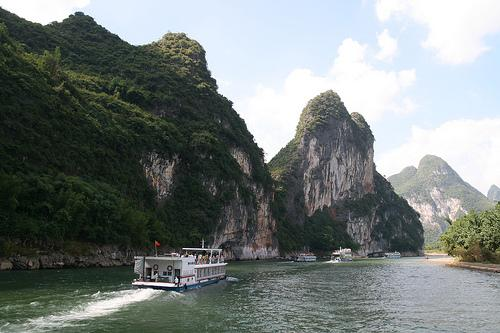Identify the color of the sky and body of water in the image. The sky displays a clear blue hue, while the body of water reveals a calm green color. Can you identify an object in the image which might symbolize safety and what color is it? There are two life rings on the back of the white boat, likely symbolizing safety in case of emergency situations. Describe the key elements of this image in the context of a tourism promotion. The image showcases scenic green river views, a sightseeing boat with ample windows and space for tourists, a beautiful blue sky, and breathtaking landscapes of rocky mountains rich in lush greenery and foliage. What does the image suggest about the activities of people on the boat? The image suggests that many people are aboard the boat, likely enjoying the sightseeing tour, with some standing on the top deck observing the natural beauty around them. What type of experience do you think the people on the boat might be having? The people on the boat are likely having a relaxing and enjoyable sightseeing experience while they take in the beautiful surrounding nature and verdant landscapes. Can you spot any evidence indicating that the boat is in motion? If so, describe it. Yes, there is evidence of the boat being in motion; the white waves and the water churned up to a white color from the boat's motor both indicate that it is moving. How many objects can you count in the image when referring to the objects that are on the water? There are three objects on the water: the main tour boat, the white waves caused by the boat, and the wake of the boat. What is the main mode of transportation in the image and what kind of environment is it in? A tour boat is the main mode of transportation, traveling on a river surrounded by mountains and rocky hills with lush greenery. In a poetic manner, describe the mood of the image. Serenely sailing through the green embrace of nature, under the watchful gaze of the azure heavens, a vessel filled with souls eager to witness the dance of sublime mountains and her aquatic partner, the river. Provide a brief caption for this image that focuses on the weather and setting. A beautiful day with a clear blue sky and puffy white clouds, as a sightseeing boat sails through a calm green river surrounded by lush mountains. 